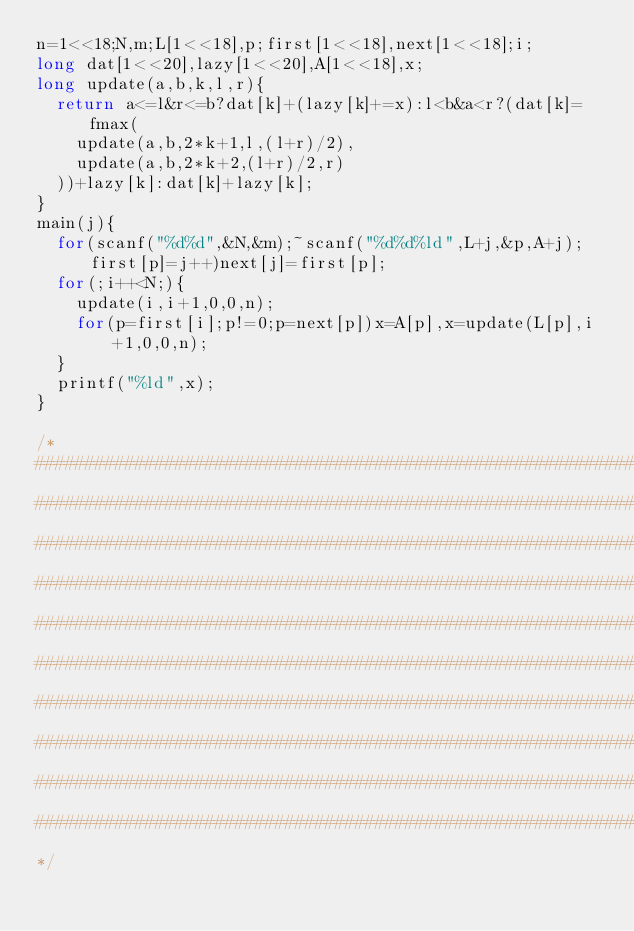Convert code to text. <code><loc_0><loc_0><loc_500><loc_500><_C_>n=1<<18;N,m;L[1<<18],p;first[1<<18],next[1<<18];i;
long dat[1<<20],lazy[1<<20],A[1<<18],x;
long update(a,b,k,l,r){
	return a<=l&r<=b?dat[k]+(lazy[k]+=x):l<b&a<r?(dat[k]=fmax(
		update(a,b,2*k+1,l,(l+r)/2),
		update(a,b,2*k+2,(l+r)/2,r)
	))+lazy[k]:dat[k]+lazy[k];
}
main(j){
	for(scanf("%d%d",&N,&m);~scanf("%d%d%ld",L+j,&p,A+j);first[p]=j++)next[j]=first[p];
	for(;i++<N;){
		update(i,i+1,0,0,n);
		for(p=first[i];p!=0;p=next[p])x=A[p],x=update(L[p],i+1,0,0,n);
	}
	printf("%ld",x);
}

/*
####################################################################################################
####################################################################################################
####################################################################################################
####################################################################################################
####################################################################################################
####################################################################################################
####################################################################################################
####################################################################################################
####################################################################################################
####################################################################################################
*/
</code> 